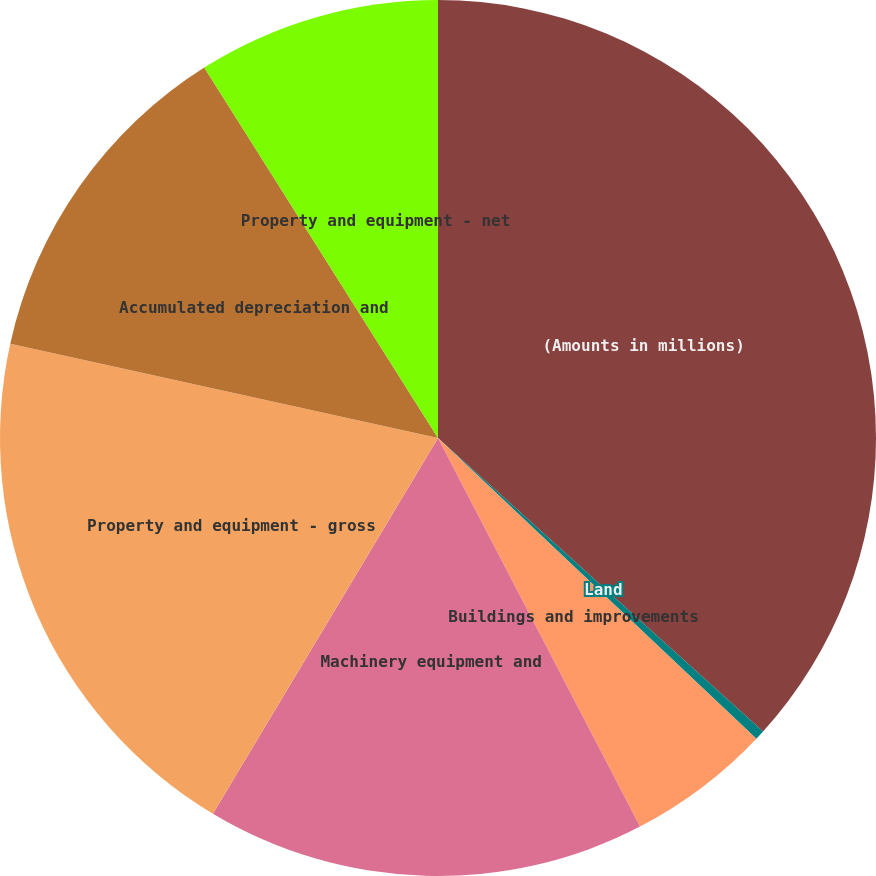<chart> <loc_0><loc_0><loc_500><loc_500><pie_chart><fcel>(Amounts in millions)<fcel>Land<fcel>Buildings and improvements<fcel>Machinery equipment and<fcel>Property and equipment - gross<fcel>Accumulated depreciation and<fcel>Property and equipment - net<nl><fcel>36.69%<fcel>0.36%<fcel>5.32%<fcel>16.22%<fcel>19.86%<fcel>12.59%<fcel>8.96%<nl></chart> 